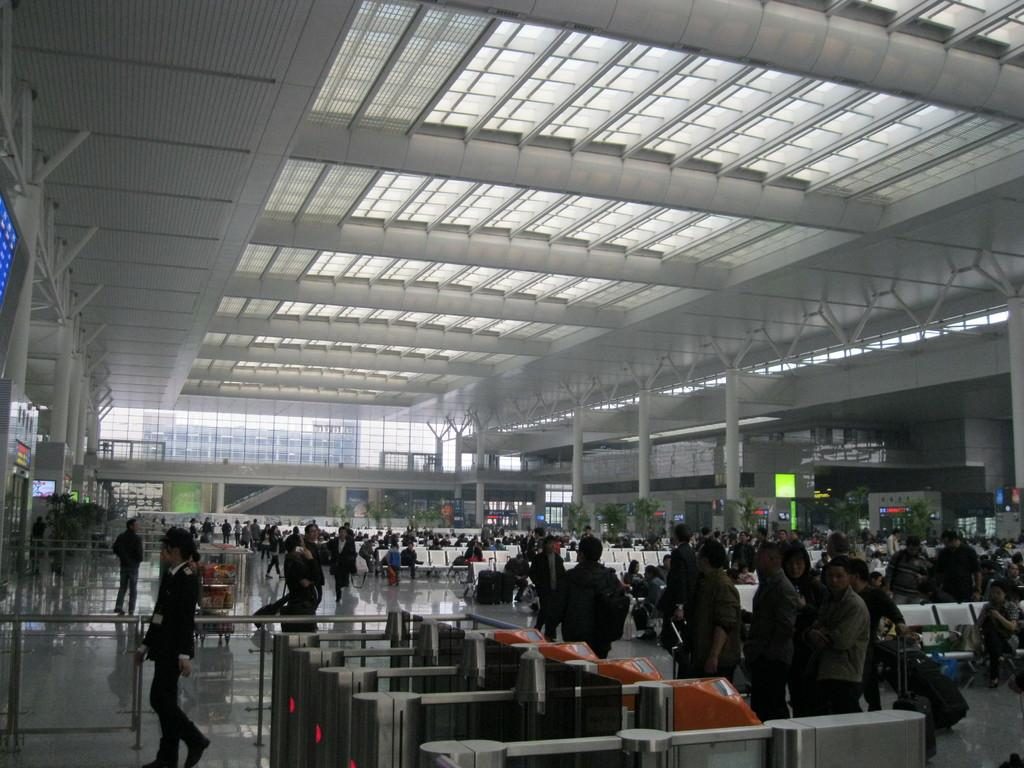What is happening on the left side of the image? There is a person walking on the left side of the image. What is the person wearing? The person is wearing a black coat. What is happening on the right side of the image? There are people walking on the right side of the image. How many rings can be seen on the person's fingers in the image? There are no rings visible on the person's fingers in the image. What part of the brain is visible in the image? There is no brain present in the image. 